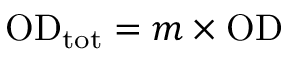Convert formula to latex. <formula><loc_0><loc_0><loc_500><loc_500>O D _ { t o t } = m \times O D</formula> 